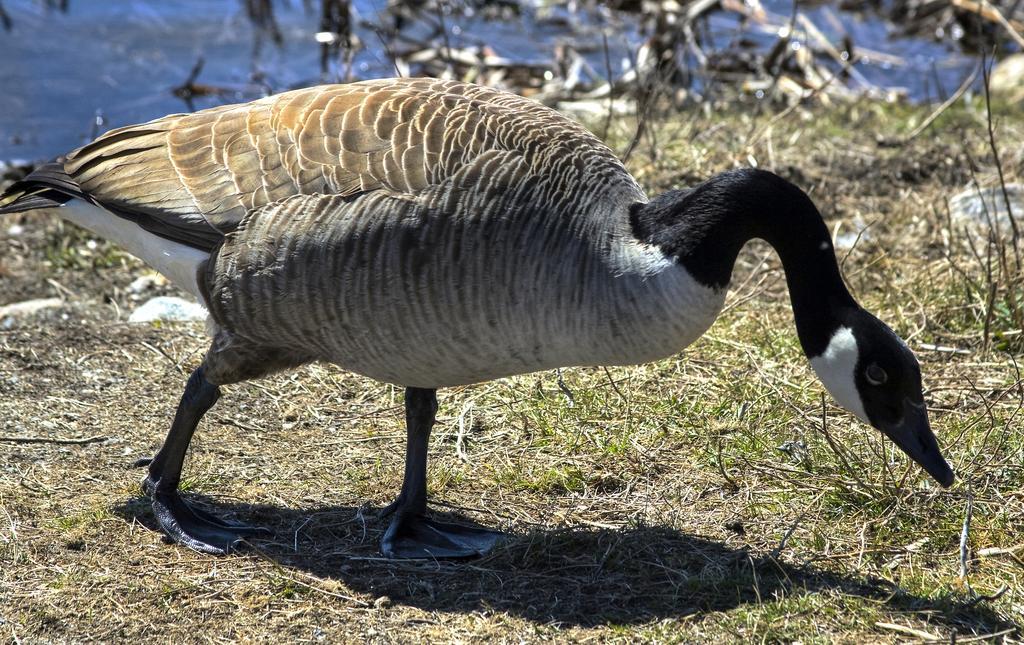How would you summarize this image in a sentence or two? This picture is clicked outside. In the center we can see a bird seems to be a goose and we can see the grass. In the background we can see the water body and some other objects. 